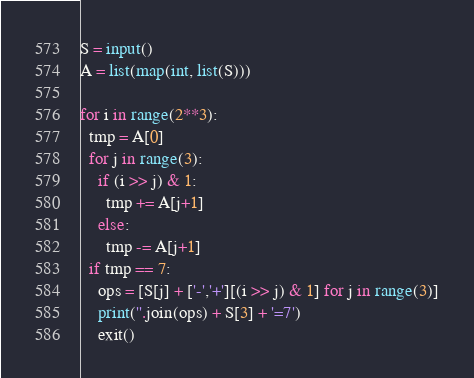Convert code to text. <code><loc_0><loc_0><loc_500><loc_500><_Python_>S = input()
A = list(map(int, list(S)))

for i in range(2**3):
  tmp = A[0]
  for j in range(3):
    if (i >> j) & 1:
      tmp += A[j+1]
    else:
      tmp -= A[j+1]
  if tmp == 7:
    ops = [S[j] + ['-','+'][(i >> j) & 1] for j in range(3)]
    print(''.join(ops) + S[3] + '=7')
    exit()</code> 